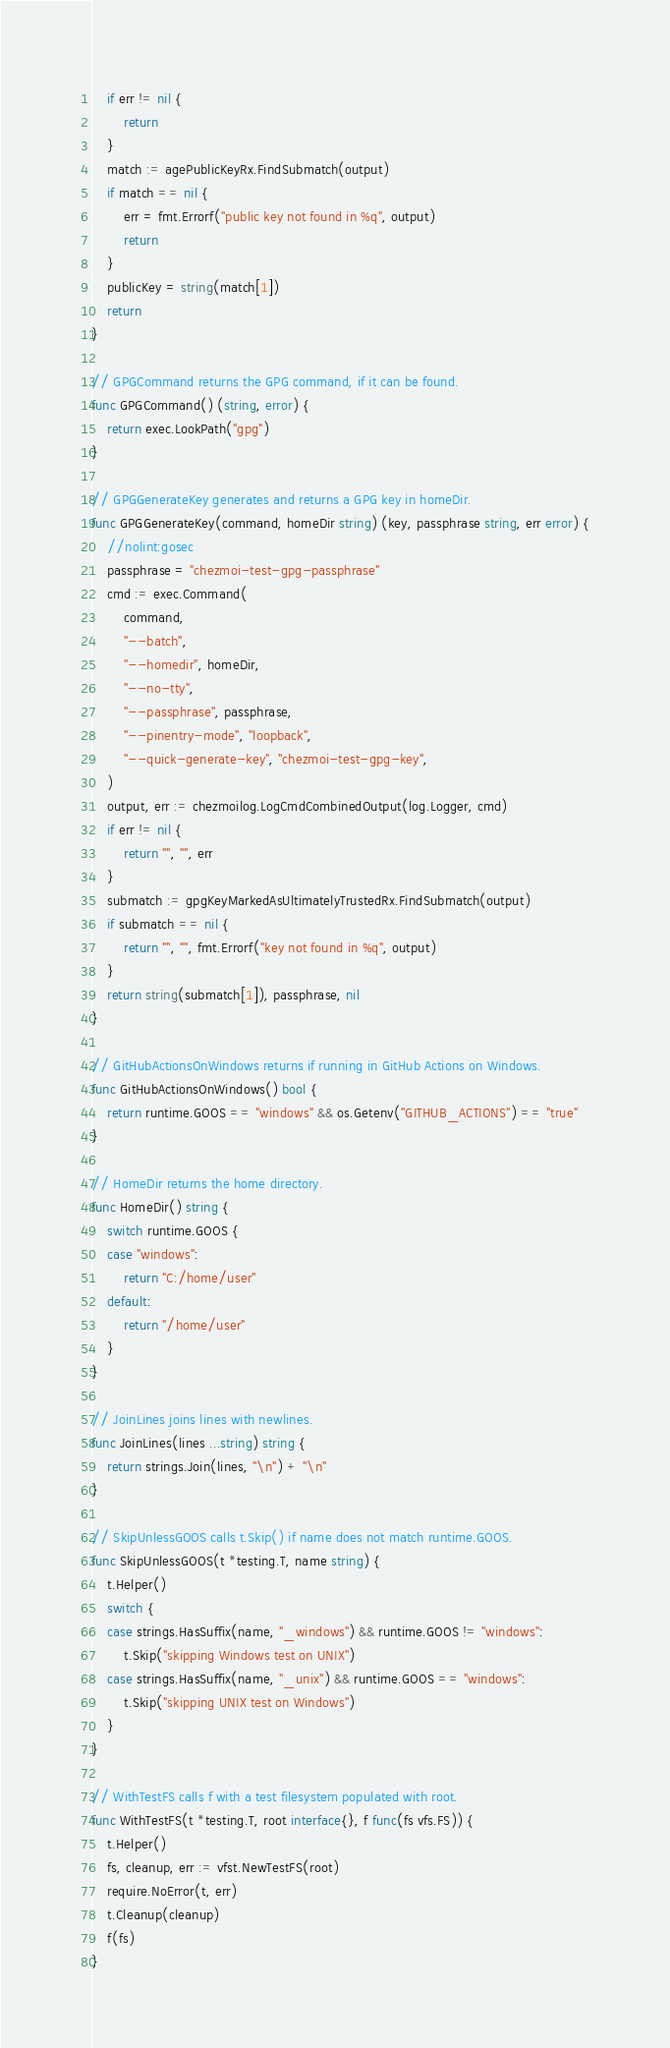Convert code to text. <code><loc_0><loc_0><loc_500><loc_500><_Go_>	if err != nil {
		return
	}
	match := agePublicKeyRx.FindSubmatch(output)
	if match == nil {
		err = fmt.Errorf("public key not found in %q", output)
		return
	}
	publicKey = string(match[1])
	return
}

// GPGCommand returns the GPG command, if it can be found.
func GPGCommand() (string, error) {
	return exec.LookPath("gpg")
}

// GPGGenerateKey generates and returns a GPG key in homeDir.
func GPGGenerateKey(command, homeDir string) (key, passphrase string, err error) {
	//nolint:gosec
	passphrase = "chezmoi-test-gpg-passphrase"
	cmd := exec.Command(
		command,
		"--batch",
		"--homedir", homeDir,
		"--no-tty",
		"--passphrase", passphrase,
		"--pinentry-mode", "loopback",
		"--quick-generate-key", "chezmoi-test-gpg-key",
	)
	output, err := chezmoilog.LogCmdCombinedOutput(log.Logger, cmd)
	if err != nil {
		return "", "", err
	}
	submatch := gpgKeyMarkedAsUltimatelyTrustedRx.FindSubmatch(output)
	if submatch == nil {
		return "", "", fmt.Errorf("key not found in %q", output)
	}
	return string(submatch[1]), passphrase, nil
}

// GitHubActionsOnWindows returns if running in GitHub Actions on Windows.
func GitHubActionsOnWindows() bool {
	return runtime.GOOS == "windows" && os.Getenv("GITHUB_ACTIONS") == "true"
}

// HomeDir returns the home directory.
func HomeDir() string {
	switch runtime.GOOS {
	case "windows":
		return "C:/home/user"
	default:
		return "/home/user"
	}
}

// JoinLines joins lines with newlines.
func JoinLines(lines ...string) string {
	return strings.Join(lines, "\n") + "\n"
}

// SkipUnlessGOOS calls t.Skip() if name does not match runtime.GOOS.
func SkipUnlessGOOS(t *testing.T, name string) {
	t.Helper()
	switch {
	case strings.HasSuffix(name, "_windows") && runtime.GOOS != "windows":
		t.Skip("skipping Windows test on UNIX")
	case strings.HasSuffix(name, "_unix") && runtime.GOOS == "windows":
		t.Skip("skipping UNIX test on Windows")
	}
}

// WithTestFS calls f with a test filesystem populated with root.
func WithTestFS(t *testing.T, root interface{}, f func(fs vfs.FS)) {
	t.Helper()
	fs, cleanup, err := vfst.NewTestFS(root)
	require.NoError(t, err)
	t.Cleanup(cleanup)
	f(fs)
}
</code> 